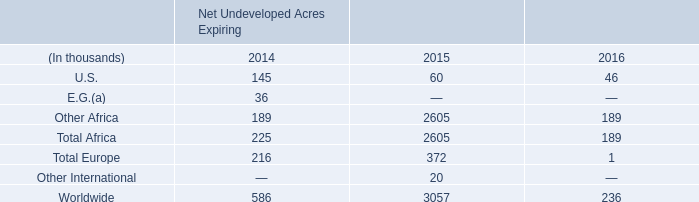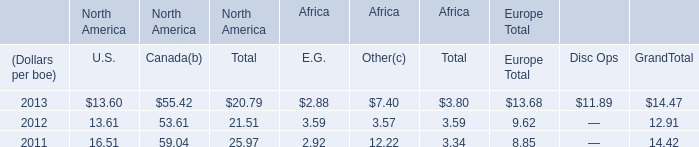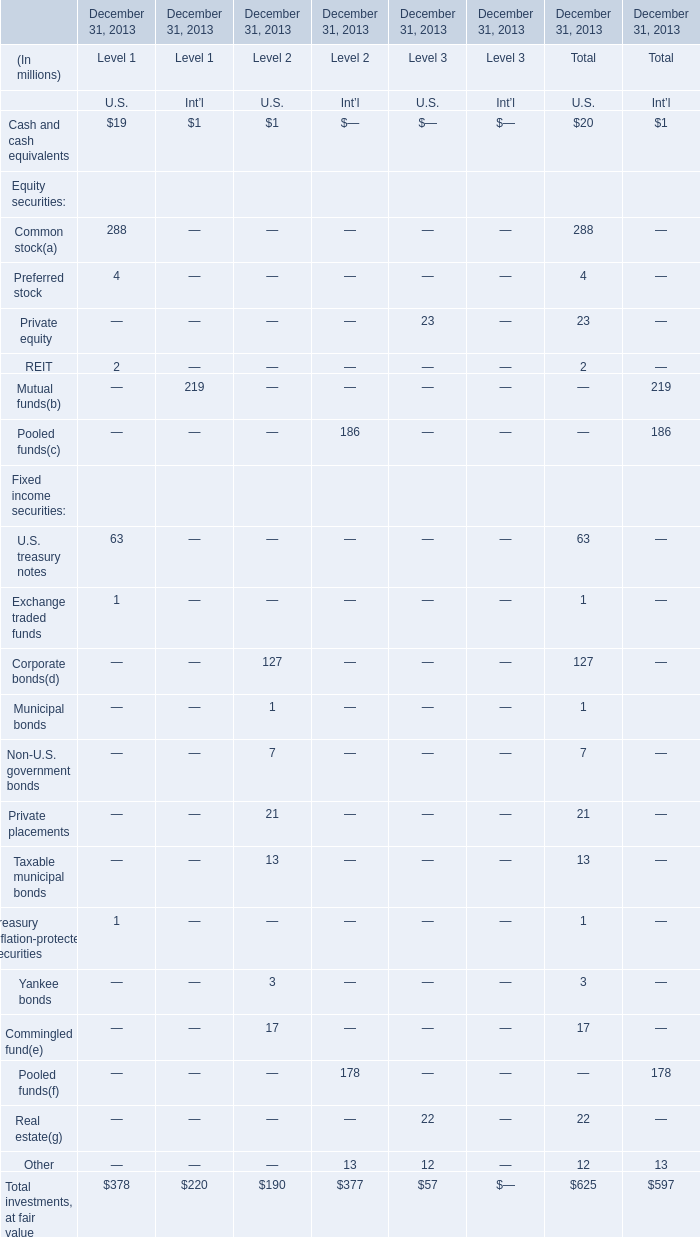What is the percentage of all elements that are positive to the total amount for U.S. of Level 2? 
Computations: ((((((((1 + 127) + 1) + 7) + 21) + 13) + 3) + 17) / 190)
Answer: 1.0. 